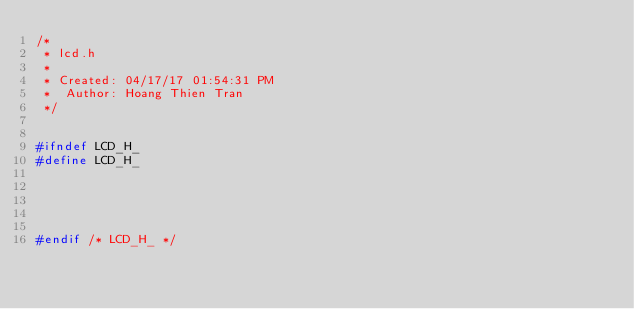Convert code to text. <code><loc_0><loc_0><loc_500><loc_500><_C_>/*
 * lcd.h
 *
 * Created: 04/17/17 01:54:31 PM
 *  Author: Hoang Thien Tran
 */ 


#ifndef LCD_H_
#define LCD_H_





#endif /* LCD_H_ */</code> 